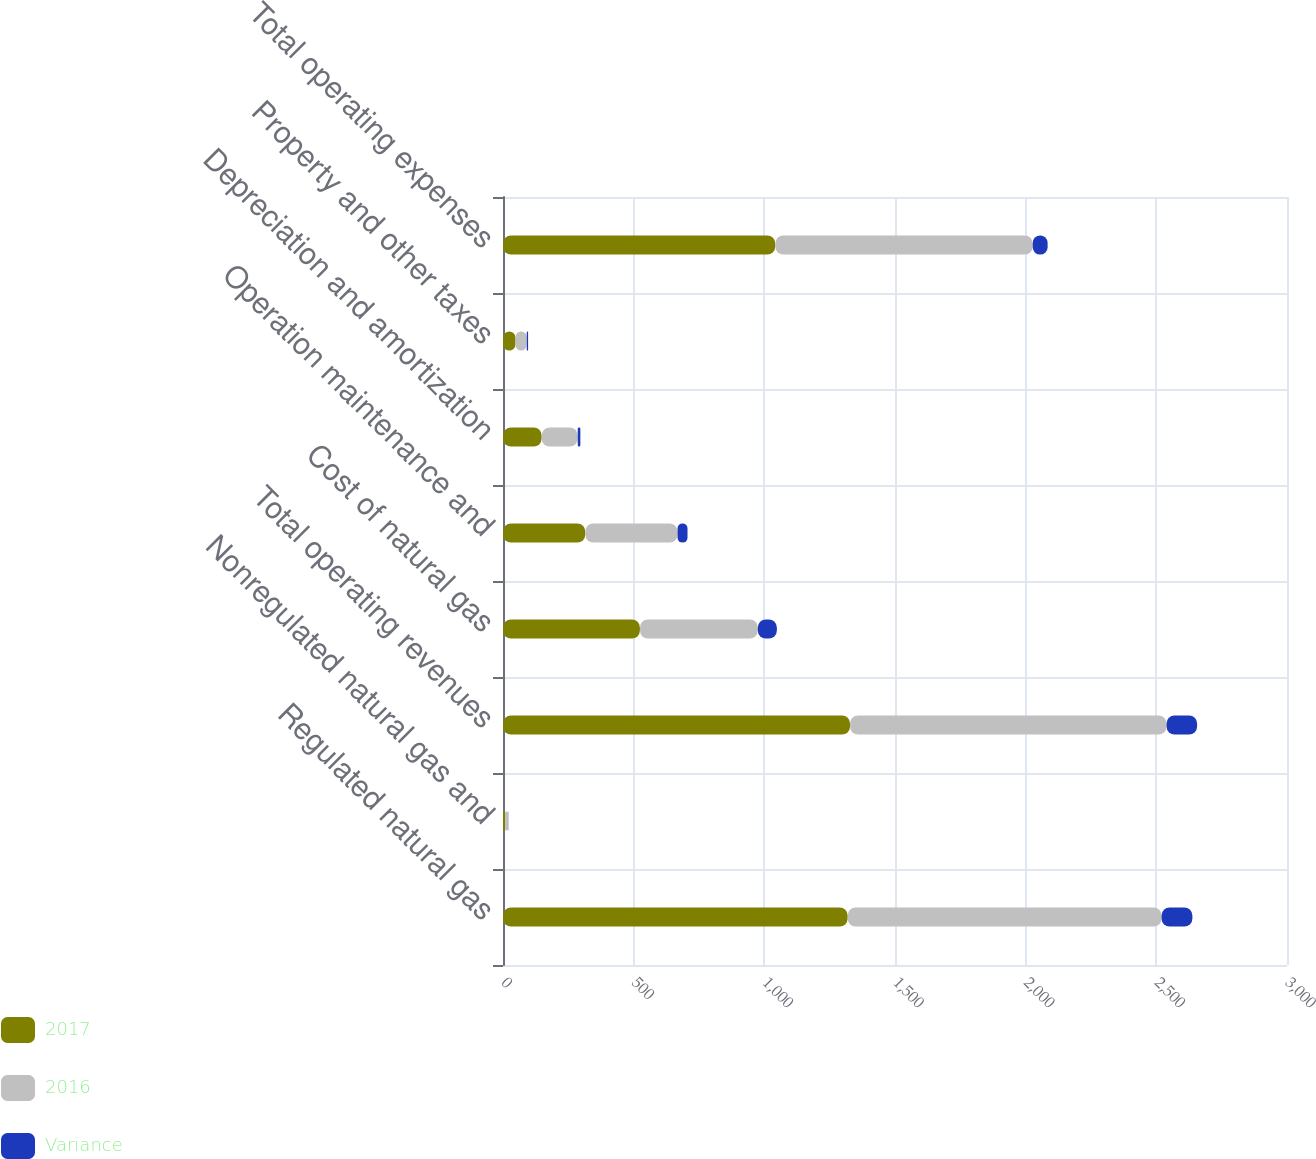<chart> <loc_0><loc_0><loc_500><loc_500><stacked_bar_chart><ecel><fcel>Regulated natural gas<fcel>Nonregulated natural gas and<fcel>Total operating revenues<fcel>Cost of natural gas<fcel>Operation maintenance and<fcel>Depreciation and amortization<fcel>Property and other taxes<fcel>Total operating expenses<nl><fcel>2017<fcel>1319<fcel>9<fcel>1328<fcel>524<fcel>315<fcel>148<fcel>48<fcel>1042<nl><fcel>2016<fcel>1201<fcel>10<fcel>1211<fcel>451<fcel>353<fcel>138<fcel>43<fcel>985<nl><fcel>Variance<fcel>118<fcel>1<fcel>117<fcel>73<fcel>38<fcel>10<fcel>5<fcel>57<nl></chart> 